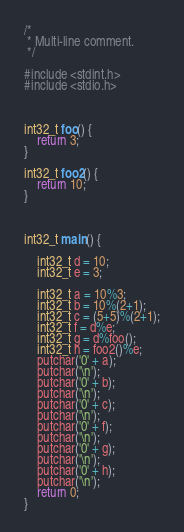<code> <loc_0><loc_0><loc_500><loc_500><_C_>/*
 * Multi-line comment.
 */

#include <stdint.h>
#include <stdio.h>



int32_t foo() {
    return 3;
}

int32_t foo2() {
    return 10;
}



int32_t main() {

    int32_t d = 10;
    int32_t e = 3;

    int32_t a = 10%3;
    int32_t b = 10%(2+1);
    int32_t c = (5+5)%(2+1);
    int32_t f = d%e;
    int32_t g = d%foo();
    int32_t h = foo2()%e;
    putchar('0' + a);
    putchar('\n');
    putchar('0' + b);
    putchar('\n');
    putchar('0' + c);
    putchar('\n');
    putchar('0' + f);
    putchar('\n');
    putchar('0' + g);
    putchar('\n');
    putchar('0' + h);
    putchar('\n');
    return 0;
}</code> 